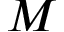<formula> <loc_0><loc_0><loc_500><loc_500>M</formula> 